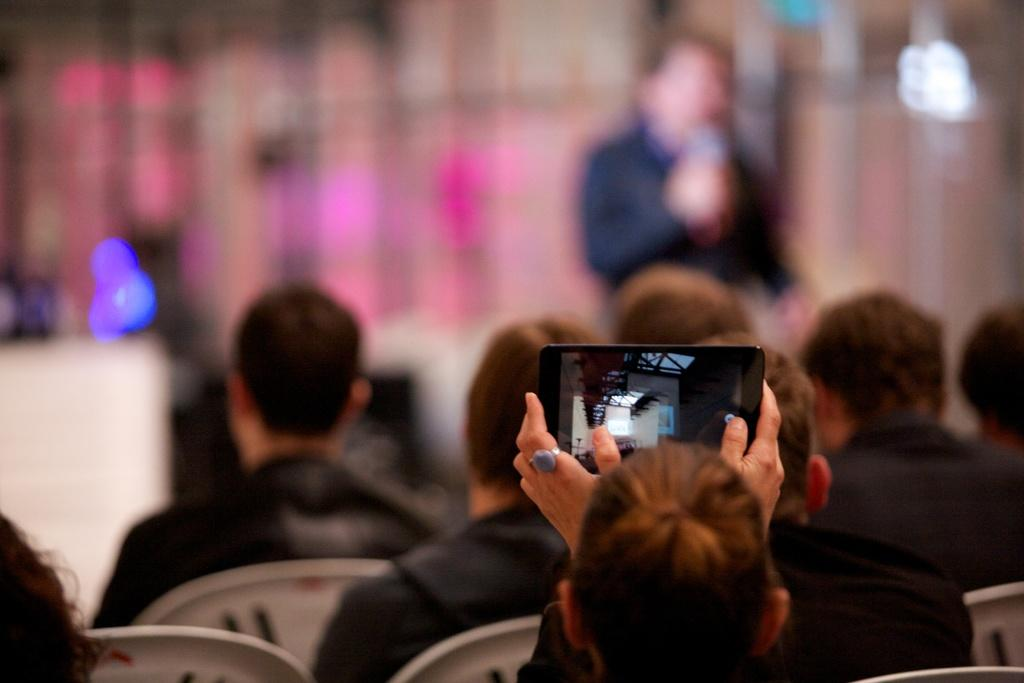What are the people in the image doing? The people in the image are sitting on chairs. What is the man in front of the people doing? The man is standing in front of the people. What object is the man holding in his hand? The man is holding a microphone in his hand. What types of toys can be seen on the floor during the party in the image? There is no party or toys present in the image; it features people sitting on chairs and a man standing with a microphone. 